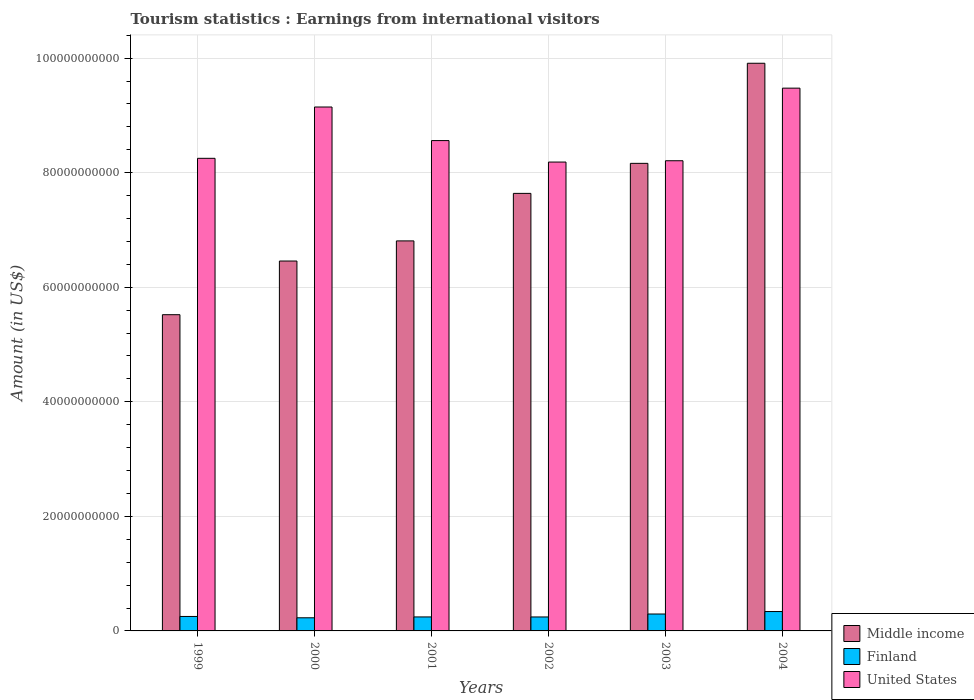How many different coloured bars are there?
Offer a terse response. 3. How many groups of bars are there?
Make the answer very short. 6. Are the number of bars per tick equal to the number of legend labels?
Provide a short and direct response. Yes. How many bars are there on the 1st tick from the right?
Your answer should be compact. 3. What is the label of the 3rd group of bars from the left?
Your answer should be compact. 2001. In how many cases, is the number of bars for a given year not equal to the number of legend labels?
Your answer should be compact. 0. What is the earnings from international visitors in Middle income in 2004?
Your answer should be compact. 9.91e+1. Across all years, what is the maximum earnings from international visitors in Middle income?
Provide a succinct answer. 9.91e+1. Across all years, what is the minimum earnings from international visitors in Middle income?
Make the answer very short. 5.52e+1. In which year was the earnings from international visitors in Finland maximum?
Give a very brief answer. 2004. What is the total earnings from international visitors in Middle income in the graph?
Provide a succinct answer. 4.45e+11. What is the difference between the earnings from international visitors in United States in 2001 and that in 2002?
Provide a succinct answer. 3.75e+09. What is the difference between the earnings from international visitors in United States in 2001 and the earnings from international visitors in Finland in 2004?
Your answer should be very brief. 8.22e+1. What is the average earnings from international visitors in Finland per year?
Keep it short and to the point. 2.67e+09. In the year 2001, what is the difference between the earnings from international visitors in Middle income and earnings from international visitors in United States?
Provide a succinct answer. -1.75e+1. In how many years, is the earnings from international visitors in Middle income greater than 80000000000 US$?
Provide a succinct answer. 2. What is the ratio of the earnings from international visitors in United States in 2000 to that in 2003?
Provide a short and direct response. 1.11. Is the earnings from international visitors in Finland in 1999 less than that in 2003?
Ensure brevity in your answer.  Yes. What is the difference between the highest and the second highest earnings from international visitors in Finland?
Offer a very short reply. 4.29e+08. What is the difference between the highest and the lowest earnings from international visitors in Finland?
Provide a succinct answer. 1.09e+09. What does the 3rd bar from the right in 2004 represents?
Make the answer very short. Middle income. Are all the bars in the graph horizontal?
Your answer should be very brief. No. What is the difference between two consecutive major ticks on the Y-axis?
Offer a terse response. 2.00e+1. Where does the legend appear in the graph?
Make the answer very short. Bottom right. How are the legend labels stacked?
Give a very brief answer. Vertical. What is the title of the graph?
Your answer should be compact. Tourism statistics : Earnings from international visitors. What is the Amount (in US$) in Middle income in 1999?
Keep it short and to the point. 5.52e+1. What is the Amount (in US$) in Finland in 1999?
Offer a terse response. 2.52e+09. What is the Amount (in US$) in United States in 1999?
Ensure brevity in your answer.  8.25e+1. What is the Amount (in US$) of Middle income in 2000?
Your answer should be compact. 6.46e+1. What is the Amount (in US$) in Finland in 2000?
Offer a very short reply. 2.29e+09. What is the Amount (in US$) of United States in 2000?
Your response must be concise. 9.15e+1. What is the Amount (in US$) of Middle income in 2001?
Your answer should be compact. 6.81e+1. What is the Amount (in US$) of Finland in 2001?
Your response must be concise. 2.44e+09. What is the Amount (in US$) of United States in 2001?
Provide a succinct answer. 8.56e+1. What is the Amount (in US$) of Middle income in 2002?
Your answer should be compact. 7.64e+1. What is the Amount (in US$) in Finland in 2002?
Offer a very short reply. 2.44e+09. What is the Amount (in US$) of United States in 2002?
Offer a terse response. 8.19e+1. What is the Amount (in US$) of Middle income in 2003?
Ensure brevity in your answer.  8.16e+1. What is the Amount (in US$) of Finland in 2003?
Ensure brevity in your answer.  2.95e+09. What is the Amount (in US$) in United States in 2003?
Your answer should be compact. 8.21e+1. What is the Amount (in US$) in Middle income in 2004?
Your response must be concise. 9.91e+1. What is the Amount (in US$) in Finland in 2004?
Offer a very short reply. 3.38e+09. What is the Amount (in US$) of United States in 2004?
Give a very brief answer. 9.48e+1. Across all years, what is the maximum Amount (in US$) in Middle income?
Give a very brief answer. 9.91e+1. Across all years, what is the maximum Amount (in US$) in Finland?
Provide a short and direct response. 3.38e+09. Across all years, what is the maximum Amount (in US$) in United States?
Keep it short and to the point. 9.48e+1. Across all years, what is the minimum Amount (in US$) in Middle income?
Keep it short and to the point. 5.52e+1. Across all years, what is the minimum Amount (in US$) in Finland?
Your answer should be compact. 2.29e+09. Across all years, what is the minimum Amount (in US$) in United States?
Give a very brief answer. 8.19e+1. What is the total Amount (in US$) of Middle income in the graph?
Offer a terse response. 4.45e+11. What is the total Amount (in US$) in Finland in the graph?
Provide a succinct answer. 1.60e+1. What is the total Amount (in US$) in United States in the graph?
Your response must be concise. 5.18e+11. What is the difference between the Amount (in US$) of Middle income in 1999 and that in 2000?
Keep it short and to the point. -9.37e+09. What is the difference between the Amount (in US$) of Finland in 1999 and that in 2000?
Offer a terse response. 2.32e+08. What is the difference between the Amount (in US$) in United States in 1999 and that in 2000?
Your answer should be compact. -8.96e+09. What is the difference between the Amount (in US$) in Middle income in 1999 and that in 2001?
Give a very brief answer. -1.29e+1. What is the difference between the Amount (in US$) in Finland in 1999 and that in 2001?
Offer a terse response. 8.30e+07. What is the difference between the Amount (in US$) in United States in 1999 and that in 2001?
Ensure brevity in your answer.  -3.10e+09. What is the difference between the Amount (in US$) in Middle income in 1999 and that in 2002?
Keep it short and to the point. -2.12e+1. What is the difference between the Amount (in US$) in Finland in 1999 and that in 2002?
Provide a short and direct response. 8.70e+07. What is the difference between the Amount (in US$) in United States in 1999 and that in 2002?
Provide a short and direct response. 6.53e+08. What is the difference between the Amount (in US$) of Middle income in 1999 and that in 2003?
Give a very brief answer. -2.64e+1. What is the difference between the Amount (in US$) of Finland in 1999 and that in 2003?
Provide a succinct answer. -4.29e+08. What is the difference between the Amount (in US$) of United States in 1999 and that in 2003?
Keep it short and to the point. 4.22e+08. What is the difference between the Amount (in US$) of Middle income in 1999 and that in 2004?
Provide a short and direct response. -4.39e+1. What is the difference between the Amount (in US$) in Finland in 1999 and that in 2004?
Give a very brief answer. -8.58e+08. What is the difference between the Amount (in US$) in United States in 1999 and that in 2004?
Provide a short and direct response. -1.23e+1. What is the difference between the Amount (in US$) of Middle income in 2000 and that in 2001?
Provide a succinct answer. -3.51e+09. What is the difference between the Amount (in US$) of Finland in 2000 and that in 2001?
Your response must be concise. -1.49e+08. What is the difference between the Amount (in US$) of United States in 2000 and that in 2001?
Give a very brief answer. 5.86e+09. What is the difference between the Amount (in US$) of Middle income in 2000 and that in 2002?
Your response must be concise. -1.18e+1. What is the difference between the Amount (in US$) of Finland in 2000 and that in 2002?
Make the answer very short. -1.45e+08. What is the difference between the Amount (in US$) of United States in 2000 and that in 2002?
Make the answer very short. 9.61e+09. What is the difference between the Amount (in US$) of Middle income in 2000 and that in 2003?
Your answer should be compact. -1.71e+1. What is the difference between the Amount (in US$) of Finland in 2000 and that in 2003?
Your answer should be compact. -6.61e+08. What is the difference between the Amount (in US$) of United States in 2000 and that in 2003?
Your answer should be very brief. 9.38e+09. What is the difference between the Amount (in US$) of Middle income in 2000 and that in 2004?
Offer a very short reply. -3.45e+1. What is the difference between the Amount (in US$) in Finland in 2000 and that in 2004?
Ensure brevity in your answer.  -1.09e+09. What is the difference between the Amount (in US$) in United States in 2000 and that in 2004?
Ensure brevity in your answer.  -3.29e+09. What is the difference between the Amount (in US$) in Middle income in 2001 and that in 2002?
Your answer should be very brief. -8.30e+09. What is the difference between the Amount (in US$) in United States in 2001 and that in 2002?
Offer a very short reply. 3.75e+09. What is the difference between the Amount (in US$) of Middle income in 2001 and that in 2003?
Offer a terse response. -1.35e+1. What is the difference between the Amount (in US$) in Finland in 2001 and that in 2003?
Provide a short and direct response. -5.12e+08. What is the difference between the Amount (in US$) of United States in 2001 and that in 2003?
Your answer should be very brief. 3.52e+09. What is the difference between the Amount (in US$) of Middle income in 2001 and that in 2004?
Keep it short and to the point. -3.10e+1. What is the difference between the Amount (in US$) in Finland in 2001 and that in 2004?
Offer a terse response. -9.41e+08. What is the difference between the Amount (in US$) in United States in 2001 and that in 2004?
Provide a short and direct response. -9.15e+09. What is the difference between the Amount (in US$) of Middle income in 2002 and that in 2003?
Offer a very short reply. -5.24e+09. What is the difference between the Amount (in US$) of Finland in 2002 and that in 2003?
Offer a very short reply. -5.16e+08. What is the difference between the Amount (in US$) in United States in 2002 and that in 2003?
Your answer should be very brief. -2.31e+08. What is the difference between the Amount (in US$) of Middle income in 2002 and that in 2004?
Make the answer very short. -2.27e+1. What is the difference between the Amount (in US$) in Finland in 2002 and that in 2004?
Give a very brief answer. -9.45e+08. What is the difference between the Amount (in US$) in United States in 2002 and that in 2004?
Offer a terse response. -1.29e+1. What is the difference between the Amount (in US$) in Middle income in 2003 and that in 2004?
Provide a short and direct response. -1.75e+1. What is the difference between the Amount (in US$) in Finland in 2003 and that in 2004?
Keep it short and to the point. -4.29e+08. What is the difference between the Amount (in US$) of United States in 2003 and that in 2004?
Provide a short and direct response. -1.27e+1. What is the difference between the Amount (in US$) of Middle income in 1999 and the Amount (in US$) of Finland in 2000?
Provide a succinct answer. 5.29e+1. What is the difference between the Amount (in US$) of Middle income in 1999 and the Amount (in US$) of United States in 2000?
Offer a very short reply. -3.63e+1. What is the difference between the Amount (in US$) in Finland in 1999 and the Amount (in US$) in United States in 2000?
Make the answer very short. -8.89e+1. What is the difference between the Amount (in US$) of Middle income in 1999 and the Amount (in US$) of Finland in 2001?
Provide a short and direct response. 5.28e+1. What is the difference between the Amount (in US$) of Middle income in 1999 and the Amount (in US$) of United States in 2001?
Offer a terse response. -3.04e+1. What is the difference between the Amount (in US$) in Finland in 1999 and the Amount (in US$) in United States in 2001?
Offer a very short reply. -8.31e+1. What is the difference between the Amount (in US$) of Middle income in 1999 and the Amount (in US$) of Finland in 2002?
Your answer should be very brief. 5.28e+1. What is the difference between the Amount (in US$) in Middle income in 1999 and the Amount (in US$) in United States in 2002?
Provide a succinct answer. -2.66e+1. What is the difference between the Amount (in US$) of Finland in 1999 and the Amount (in US$) of United States in 2002?
Offer a very short reply. -7.93e+1. What is the difference between the Amount (in US$) in Middle income in 1999 and the Amount (in US$) in Finland in 2003?
Offer a very short reply. 5.23e+1. What is the difference between the Amount (in US$) in Middle income in 1999 and the Amount (in US$) in United States in 2003?
Keep it short and to the point. -2.69e+1. What is the difference between the Amount (in US$) in Finland in 1999 and the Amount (in US$) in United States in 2003?
Make the answer very short. -7.96e+1. What is the difference between the Amount (in US$) of Middle income in 1999 and the Amount (in US$) of Finland in 2004?
Provide a succinct answer. 5.18e+1. What is the difference between the Amount (in US$) of Middle income in 1999 and the Amount (in US$) of United States in 2004?
Provide a short and direct response. -3.96e+1. What is the difference between the Amount (in US$) in Finland in 1999 and the Amount (in US$) in United States in 2004?
Your response must be concise. -9.22e+1. What is the difference between the Amount (in US$) of Middle income in 2000 and the Amount (in US$) of Finland in 2001?
Keep it short and to the point. 6.21e+1. What is the difference between the Amount (in US$) in Middle income in 2000 and the Amount (in US$) in United States in 2001?
Give a very brief answer. -2.10e+1. What is the difference between the Amount (in US$) of Finland in 2000 and the Amount (in US$) of United States in 2001?
Give a very brief answer. -8.33e+1. What is the difference between the Amount (in US$) of Middle income in 2000 and the Amount (in US$) of Finland in 2002?
Make the answer very short. 6.21e+1. What is the difference between the Amount (in US$) in Middle income in 2000 and the Amount (in US$) in United States in 2002?
Offer a terse response. -1.73e+1. What is the difference between the Amount (in US$) in Finland in 2000 and the Amount (in US$) in United States in 2002?
Give a very brief answer. -7.96e+1. What is the difference between the Amount (in US$) of Middle income in 2000 and the Amount (in US$) of Finland in 2003?
Make the answer very short. 6.16e+1. What is the difference between the Amount (in US$) of Middle income in 2000 and the Amount (in US$) of United States in 2003?
Your response must be concise. -1.75e+1. What is the difference between the Amount (in US$) in Finland in 2000 and the Amount (in US$) in United States in 2003?
Ensure brevity in your answer.  -7.98e+1. What is the difference between the Amount (in US$) in Middle income in 2000 and the Amount (in US$) in Finland in 2004?
Make the answer very short. 6.12e+1. What is the difference between the Amount (in US$) of Middle income in 2000 and the Amount (in US$) of United States in 2004?
Your answer should be compact. -3.02e+1. What is the difference between the Amount (in US$) of Finland in 2000 and the Amount (in US$) of United States in 2004?
Keep it short and to the point. -9.25e+1. What is the difference between the Amount (in US$) in Middle income in 2001 and the Amount (in US$) in Finland in 2002?
Ensure brevity in your answer.  6.57e+1. What is the difference between the Amount (in US$) in Middle income in 2001 and the Amount (in US$) in United States in 2002?
Provide a short and direct response. -1.38e+1. What is the difference between the Amount (in US$) of Finland in 2001 and the Amount (in US$) of United States in 2002?
Keep it short and to the point. -7.94e+1. What is the difference between the Amount (in US$) in Middle income in 2001 and the Amount (in US$) in Finland in 2003?
Offer a terse response. 6.51e+1. What is the difference between the Amount (in US$) of Middle income in 2001 and the Amount (in US$) of United States in 2003?
Your answer should be very brief. -1.40e+1. What is the difference between the Amount (in US$) of Finland in 2001 and the Amount (in US$) of United States in 2003?
Your response must be concise. -7.96e+1. What is the difference between the Amount (in US$) of Middle income in 2001 and the Amount (in US$) of Finland in 2004?
Provide a succinct answer. 6.47e+1. What is the difference between the Amount (in US$) of Middle income in 2001 and the Amount (in US$) of United States in 2004?
Ensure brevity in your answer.  -2.67e+1. What is the difference between the Amount (in US$) in Finland in 2001 and the Amount (in US$) in United States in 2004?
Offer a very short reply. -9.23e+1. What is the difference between the Amount (in US$) in Middle income in 2002 and the Amount (in US$) in Finland in 2003?
Ensure brevity in your answer.  7.34e+1. What is the difference between the Amount (in US$) in Middle income in 2002 and the Amount (in US$) in United States in 2003?
Offer a very short reply. -5.70e+09. What is the difference between the Amount (in US$) in Finland in 2002 and the Amount (in US$) in United States in 2003?
Provide a succinct answer. -7.97e+1. What is the difference between the Amount (in US$) in Middle income in 2002 and the Amount (in US$) in Finland in 2004?
Your answer should be very brief. 7.30e+1. What is the difference between the Amount (in US$) of Middle income in 2002 and the Amount (in US$) of United States in 2004?
Your answer should be very brief. -1.84e+1. What is the difference between the Amount (in US$) of Finland in 2002 and the Amount (in US$) of United States in 2004?
Provide a succinct answer. -9.23e+1. What is the difference between the Amount (in US$) in Middle income in 2003 and the Amount (in US$) in Finland in 2004?
Offer a very short reply. 7.83e+1. What is the difference between the Amount (in US$) in Middle income in 2003 and the Amount (in US$) in United States in 2004?
Make the answer very short. -1.31e+1. What is the difference between the Amount (in US$) in Finland in 2003 and the Amount (in US$) in United States in 2004?
Keep it short and to the point. -9.18e+1. What is the average Amount (in US$) in Middle income per year?
Your answer should be very brief. 7.42e+1. What is the average Amount (in US$) in Finland per year?
Ensure brevity in your answer.  2.67e+09. What is the average Amount (in US$) in United States per year?
Offer a very short reply. 8.64e+1. In the year 1999, what is the difference between the Amount (in US$) in Middle income and Amount (in US$) in Finland?
Give a very brief answer. 5.27e+1. In the year 1999, what is the difference between the Amount (in US$) in Middle income and Amount (in US$) in United States?
Your answer should be very brief. -2.73e+1. In the year 1999, what is the difference between the Amount (in US$) in Finland and Amount (in US$) in United States?
Give a very brief answer. -8.00e+1. In the year 2000, what is the difference between the Amount (in US$) of Middle income and Amount (in US$) of Finland?
Your response must be concise. 6.23e+1. In the year 2000, what is the difference between the Amount (in US$) of Middle income and Amount (in US$) of United States?
Keep it short and to the point. -2.69e+1. In the year 2000, what is the difference between the Amount (in US$) in Finland and Amount (in US$) in United States?
Provide a succinct answer. -8.92e+1. In the year 2001, what is the difference between the Amount (in US$) of Middle income and Amount (in US$) of Finland?
Offer a very short reply. 6.57e+1. In the year 2001, what is the difference between the Amount (in US$) in Middle income and Amount (in US$) in United States?
Provide a short and direct response. -1.75e+1. In the year 2001, what is the difference between the Amount (in US$) in Finland and Amount (in US$) in United States?
Make the answer very short. -8.32e+1. In the year 2002, what is the difference between the Amount (in US$) in Middle income and Amount (in US$) in Finland?
Provide a succinct answer. 7.40e+1. In the year 2002, what is the difference between the Amount (in US$) of Middle income and Amount (in US$) of United States?
Give a very brief answer. -5.47e+09. In the year 2002, what is the difference between the Amount (in US$) of Finland and Amount (in US$) of United States?
Your answer should be very brief. -7.94e+1. In the year 2003, what is the difference between the Amount (in US$) of Middle income and Amount (in US$) of Finland?
Provide a succinct answer. 7.87e+1. In the year 2003, what is the difference between the Amount (in US$) in Middle income and Amount (in US$) in United States?
Ensure brevity in your answer.  -4.57e+08. In the year 2003, what is the difference between the Amount (in US$) in Finland and Amount (in US$) in United States?
Offer a very short reply. -7.91e+1. In the year 2004, what is the difference between the Amount (in US$) of Middle income and Amount (in US$) of Finland?
Keep it short and to the point. 9.57e+1. In the year 2004, what is the difference between the Amount (in US$) in Middle income and Amount (in US$) in United States?
Provide a short and direct response. 4.35e+09. In the year 2004, what is the difference between the Amount (in US$) in Finland and Amount (in US$) in United States?
Your answer should be very brief. -9.14e+1. What is the ratio of the Amount (in US$) in Middle income in 1999 to that in 2000?
Ensure brevity in your answer.  0.85. What is the ratio of the Amount (in US$) of Finland in 1999 to that in 2000?
Ensure brevity in your answer.  1.1. What is the ratio of the Amount (in US$) of United States in 1999 to that in 2000?
Offer a terse response. 0.9. What is the ratio of the Amount (in US$) of Middle income in 1999 to that in 2001?
Provide a short and direct response. 0.81. What is the ratio of the Amount (in US$) in Finland in 1999 to that in 2001?
Your answer should be compact. 1.03. What is the ratio of the Amount (in US$) of United States in 1999 to that in 2001?
Your answer should be very brief. 0.96. What is the ratio of the Amount (in US$) in Middle income in 1999 to that in 2002?
Provide a short and direct response. 0.72. What is the ratio of the Amount (in US$) in Finland in 1999 to that in 2002?
Give a very brief answer. 1.04. What is the ratio of the Amount (in US$) of Middle income in 1999 to that in 2003?
Your answer should be very brief. 0.68. What is the ratio of the Amount (in US$) in Finland in 1999 to that in 2003?
Your response must be concise. 0.85. What is the ratio of the Amount (in US$) of United States in 1999 to that in 2003?
Ensure brevity in your answer.  1.01. What is the ratio of the Amount (in US$) in Middle income in 1999 to that in 2004?
Ensure brevity in your answer.  0.56. What is the ratio of the Amount (in US$) in Finland in 1999 to that in 2004?
Ensure brevity in your answer.  0.75. What is the ratio of the Amount (in US$) of United States in 1999 to that in 2004?
Your response must be concise. 0.87. What is the ratio of the Amount (in US$) in Middle income in 2000 to that in 2001?
Your response must be concise. 0.95. What is the ratio of the Amount (in US$) of Finland in 2000 to that in 2001?
Make the answer very short. 0.94. What is the ratio of the Amount (in US$) of United States in 2000 to that in 2001?
Your answer should be compact. 1.07. What is the ratio of the Amount (in US$) in Middle income in 2000 to that in 2002?
Make the answer very short. 0.85. What is the ratio of the Amount (in US$) of Finland in 2000 to that in 2002?
Your answer should be very brief. 0.94. What is the ratio of the Amount (in US$) in United States in 2000 to that in 2002?
Keep it short and to the point. 1.12. What is the ratio of the Amount (in US$) in Middle income in 2000 to that in 2003?
Give a very brief answer. 0.79. What is the ratio of the Amount (in US$) in Finland in 2000 to that in 2003?
Your answer should be compact. 0.78. What is the ratio of the Amount (in US$) in United States in 2000 to that in 2003?
Ensure brevity in your answer.  1.11. What is the ratio of the Amount (in US$) of Middle income in 2000 to that in 2004?
Provide a succinct answer. 0.65. What is the ratio of the Amount (in US$) of Finland in 2000 to that in 2004?
Offer a terse response. 0.68. What is the ratio of the Amount (in US$) of United States in 2000 to that in 2004?
Offer a very short reply. 0.97. What is the ratio of the Amount (in US$) in Middle income in 2001 to that in 2002?
Keep it short and to the point. 0.89. What is the ratio of the Amount (in US$) in Finland in 2001 to that in 2002?
Provide a short and direct response. 1. What is the ratio of the Amount (in US$) of United States in 2001 to that in 2002?
Provide a succinct answer. 1.05. What is the ratio of the Amount (in US$) in Middle income in 2001 to that in 2003?
Your answer should be compact. 0.83. What is the ratio of the Amount (in US$) of Finland in 2001 to that in 2003?
Offer a terse response. 0.83. What is the ratio of the Amount (in US$) in United States in 2001 to that in 2003?
Offer a terse response. 1.04. What is the ratio of the Amount (in US$) in Middle income in 2001 to that in 2004?
Provide a succinct answer. 0.69. What is the ratio of the Amount (in US$) of Finland in 2001 to that in 2004?
Your answer should be compact. 0.72. What is the ratio of the Amount (in US$) of United States in 2001 to that in 2004?
Keep it short and to the point. 0.9. What is the ratio of the Amount (in US$) in Middle income in 2002 to that in 2003?
Give a very brief answer. 0.94. What is the ratio of the Amount (in US$) in Finland in 2002 to that in 2003?
Your response must be concise. 0.83. What is the ratio of the Amount (in US$) in Middle income in 2002 to that in 2004?
Keep it short and to the point. 0.77. What is the ratio of the Amount (in US$) in Finland in 2002 to that in 2004?
Provide a succinct answer. 0.72. What is the ratio of the Amount (in US$) of United States in 2002 to that in 2004?
Make the answer very short. 0.86. What is the ratio of the Amount (in US$) in Middle income in 2003 to that in 2004?
Ensure brevity in your answer.  0.82. What is the ratio of the Amount (in US$) in Finland in 2003 to that in 2004?
Your response must be concise. 0.87. What is the ratio of the Amount (in US$) in United States in 2003 to that in 2004?
Provide a succinct answer. 0.87. What is the difference between the highest and the second highest Amount (in US$) of Middle income?
Offer a very short reply. 1.75e+1. What is the difference between the highest and the second highest Amount (in US$) in Finland?
Provide a short and direct response. 4.29e+08. What is the difference between the highest and the second highest Amount (in US$) of United States?
Keep it short and to the point. 3.29e+09. What is the difference between the highest and the lowest Amount (in US$) of Middle income?
Offer a terse response. 4.39e+1. What is the difference between the highest and the lowest Amount (in US$) in Finland?
Keep it short and to the point. 1.09e+09. What is the difference between the highest and the lowest Amount (in US$) of United States?
Provide a succinct answer. 1.29e+1. 